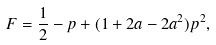Convert formula to latex. <formula><loc_0><loc_0><loc_500><loc_500>F = \frac { 1 } { 2 } - p + ( 1 + 2 a - 2 a ^ { 2 } ) p ^ { 2 } ,</formula> 